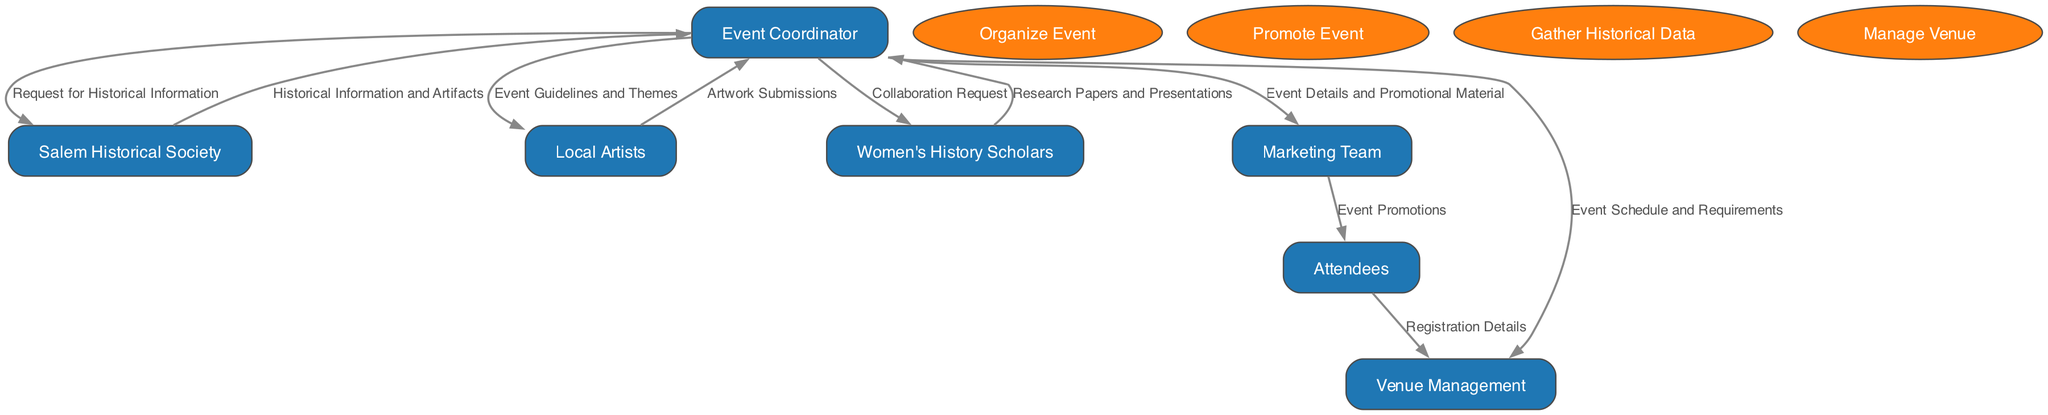What is the role of the Event Coordinator? The Event Coordinator is responsible for the overall organization of the event, coordinating with various entities and managing different processes such as promotion, gathering historical data, and venue management.
Answer: overall organization How many entities are involved in the diagram? By counting the unique entities listed in the diagram, including the Event Coordinator, Salem Historical Society, Local Artists, Women's History Scholars, Marketing Team, Venue Management, and Attendees, I find a total of seven entities.
Answer: 7 What data does the Event Coordinator send to the Marketing Team? The Event Coordinator sends Event Details and Promotional Material to the Marketing Team to facilitate the promotion of the event.
Answer: Event Details and Promotional Material Who provides Artwork Submissions? The Local Artists provide Artwork Submissions, which are created based on the guidelines and themes set forth by the Event Coordinator.
Answer: Local Artists What is the first data flow from the Event Coordinator? The first data flow from the Event Coordinator is a Request for Historical Information sent to the Salem Historical Society, initiating the process of gathering historical content for the event.
Answer: Request for Historical Information What is the process of managing the venue? The process of managing the venue involves coordinating with the Venue Management team regarding the event schedule and requirements, ensuring that all logistics are handled appropriately for a successful event.
Answer: Manage Venue How many data flows originate from the Event Coordinator? The Event Coordinator sends a total of four data flows: to the Salem Historical Society, Local Artists, Women's History Scholars, and Marketing Team, which indicates the coordination role played by the coordinator.
Answer: 4 Which entity receives Event Promotions? The Marketing Team sends Event Promotions to the Attendees, whose interest in the event is captured through promotional efforts, thereby enhancing attendance.
Answer: Attendees What is the role of Women's History Scholars in the event? The Women's History Scholars provide insights, research papers, and presentations that enrich the event's content and educational value, contributing to a deeper understanding of women's history in Salem.
Answer: Experts providing insights 